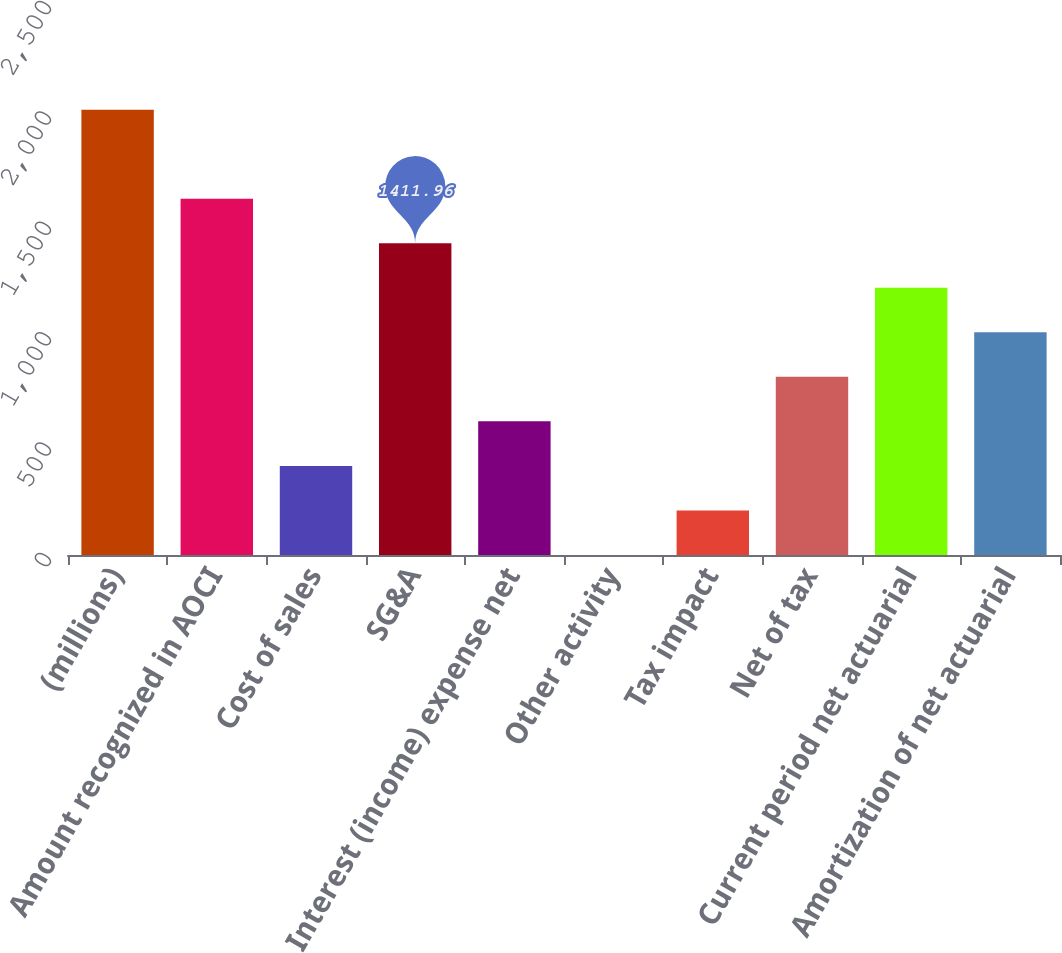<chart> <loc_0><loc_0><loc_500><loc_500><bar_chart><fcel>(millions)<fcel>Amount recognized in AOCI<fcel>Cost of sales<fcel>SG&A<fcel>Interest (income) expense net<fcel>Other activity<fcel>Tax impact<fcel>Net of tax<fcel>Current period net actuarial<fcel>Amortization of net actuarial<nl><fcel>2017<fcel>1613.64<fcel>403.56<fcel>1411.96<fcel>605.24<fcel>0.2<fcel>201.88<fcel>806.92<fcel>1210.28<fcel>1008.6<nl></chart> 